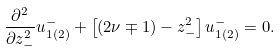Convert formula to latex. <formula><loc_0><loc_0><loc_500><loc_500>\frac { { \partial } ^ { 2 } } { { \partial } z _ { - } ^ { 2 } } u _ { 1 ( 2 ) } ^ { - } + \left [ ( 2 \nu \mp 1 ) - z _ { - } ^ { 2 } \right ] u _ { 1 ( 2 ) } ^ { - } = 0 .</formula> 